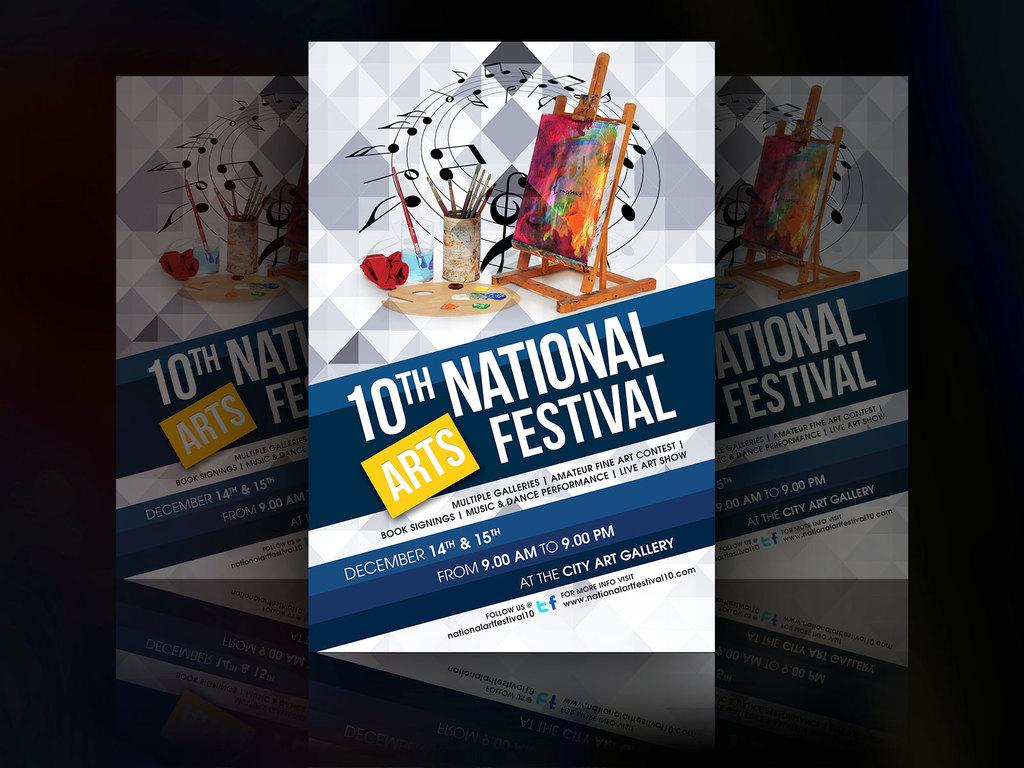<image>
Relay a brief, clear account of the picture shown. Several posters for the 10th National Arts Festival. 